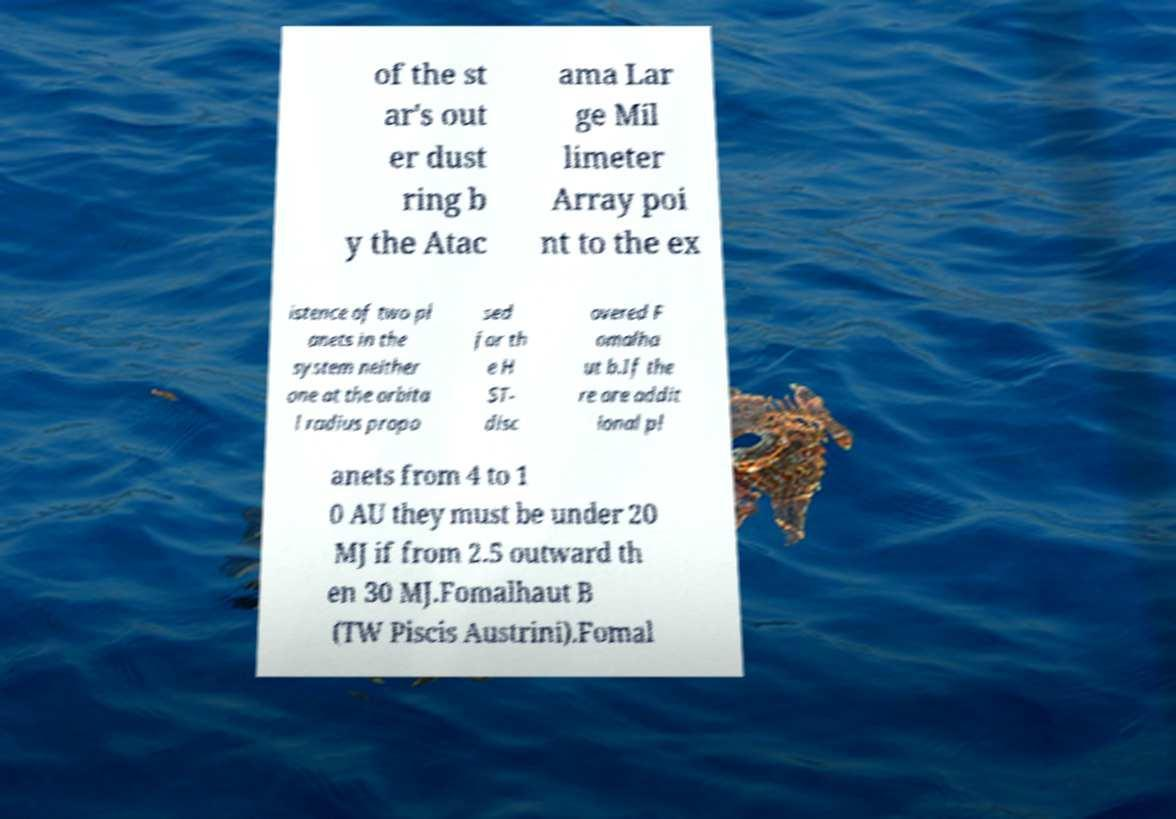I need the written content from this picture converted into text. Can you do that? of the st ar's out er dust ring b y the Atac ama Lar ge Mil limeter Array poi nt to the ex istence of two pl anets in the system neither one at the orbita l radius propo sed for th e H ST- disc overed F omalha ut b.If the re are addit ional pl anets from 4 to 1 0 AU they must be under 20 MJ if from 2.5 outward th en 30 MJ.Fomalhaut B (TW Piscis Austrini).Fomal 